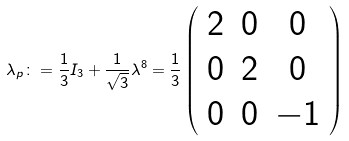Convert formula to latex. <formula><loc_0><loc_0><loc_500><loc_500>\lambda _ { p } \colon = \frac { 1 } { 3 } I _ { 3 } + \frac { 1 } { \sqrt { 3 } } \lambda ^ { 8 } = \frac { 1 } { 3 } \left ( \begin{array} { c c c } 2 & 0 & 0 \\ 0 & 2 & 0 \\ 0 & 0 & - 1 \end{array} \right ) \\</formula> 